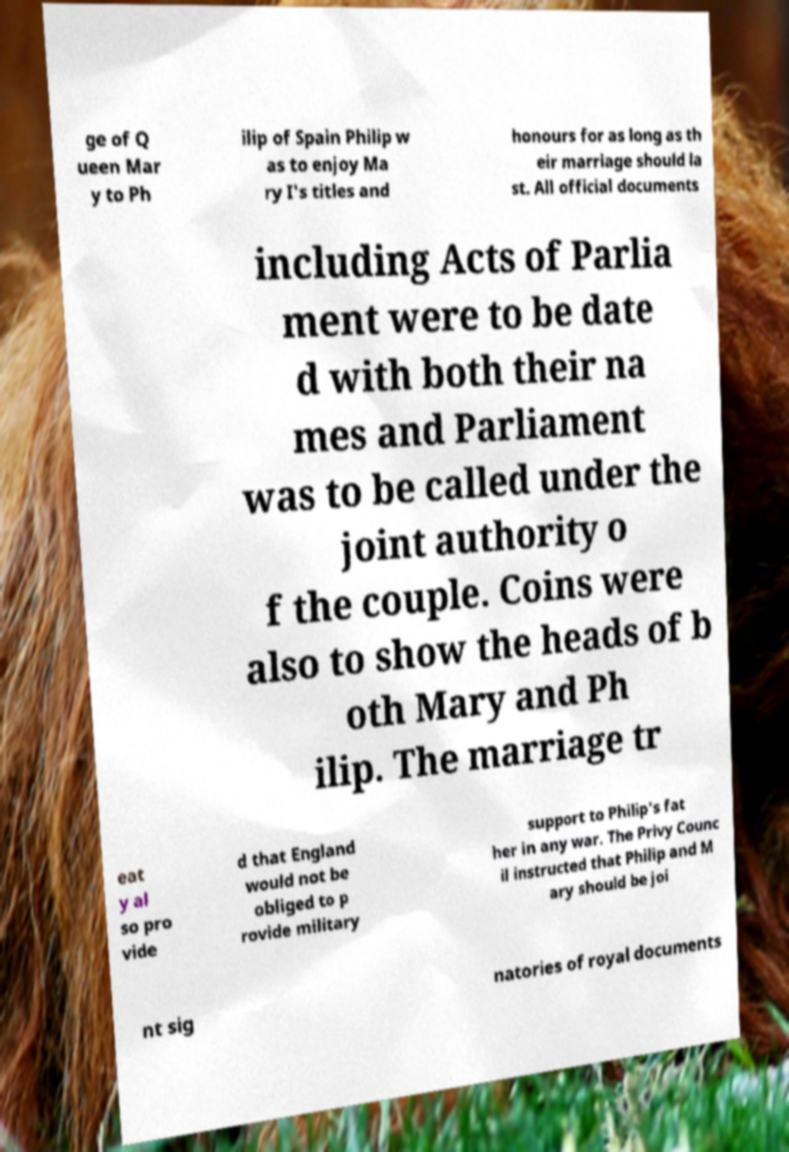I need the written content from this picture converted into text. Can you do that? ge of Q ueen Mar y to Ph ilip of Spain Philip w as to enjoy Ma ry I's titles and honours for as long as th eir marriage should la st. All official documents including Acts of Parlia ment were to be date d with both their na mes and Parliament was to be called under the joint authority o f the couple. Coins were also to show the heads of b oth Mary and Ph ilip. The marriage tr eat y al so pro vide d that England would not be obliged to p rovide military support to Philip's fat her in any war. The Privy Counc il instructed that Philip and M ary should be joi nt sig natories of royal documents 